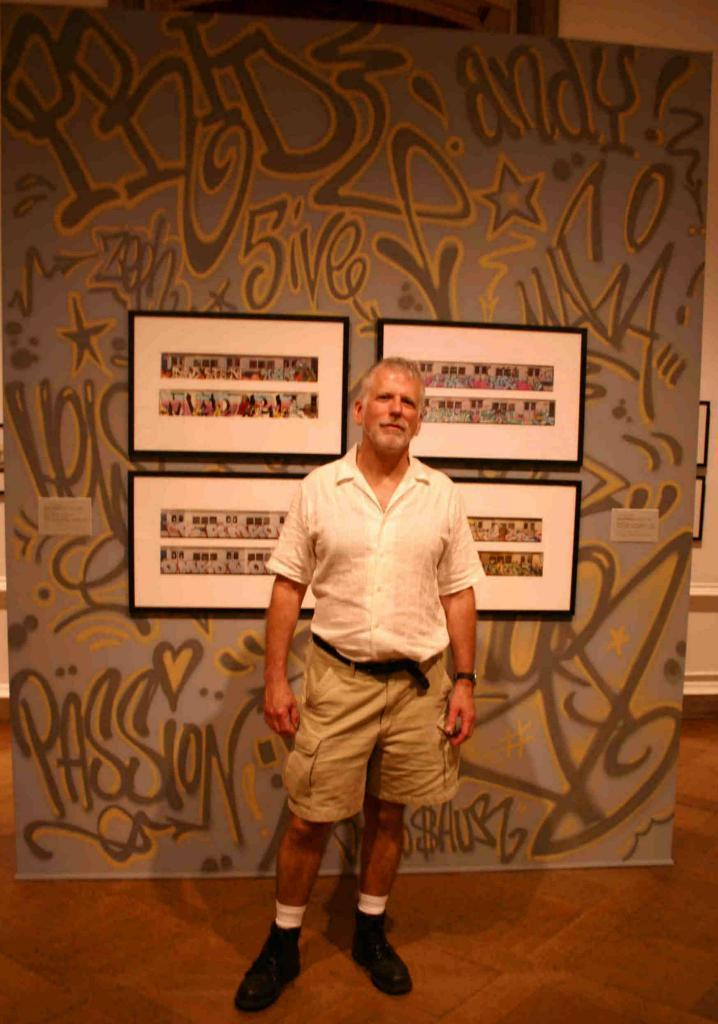Who or what is the main subject in the image? There is a person in the image. What is the person wearing? The person is wearing a white shirt. What is the person's posture in the image? The person is standing. What can be seen on the wall in the background? There are four photo frames attached to the wall in the background. How does the person in the image treat their wound? There is no wound visible on the person in the image. What expertise does the person in the image have? The image does not provide any information about the person's expertise. 